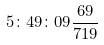<formula> <loc_0><loc_0><loc_500><loc_500>5 \colon 4 9 \colon 0 9 \frac { 6 9 } { 7 1 9 }</formula> 